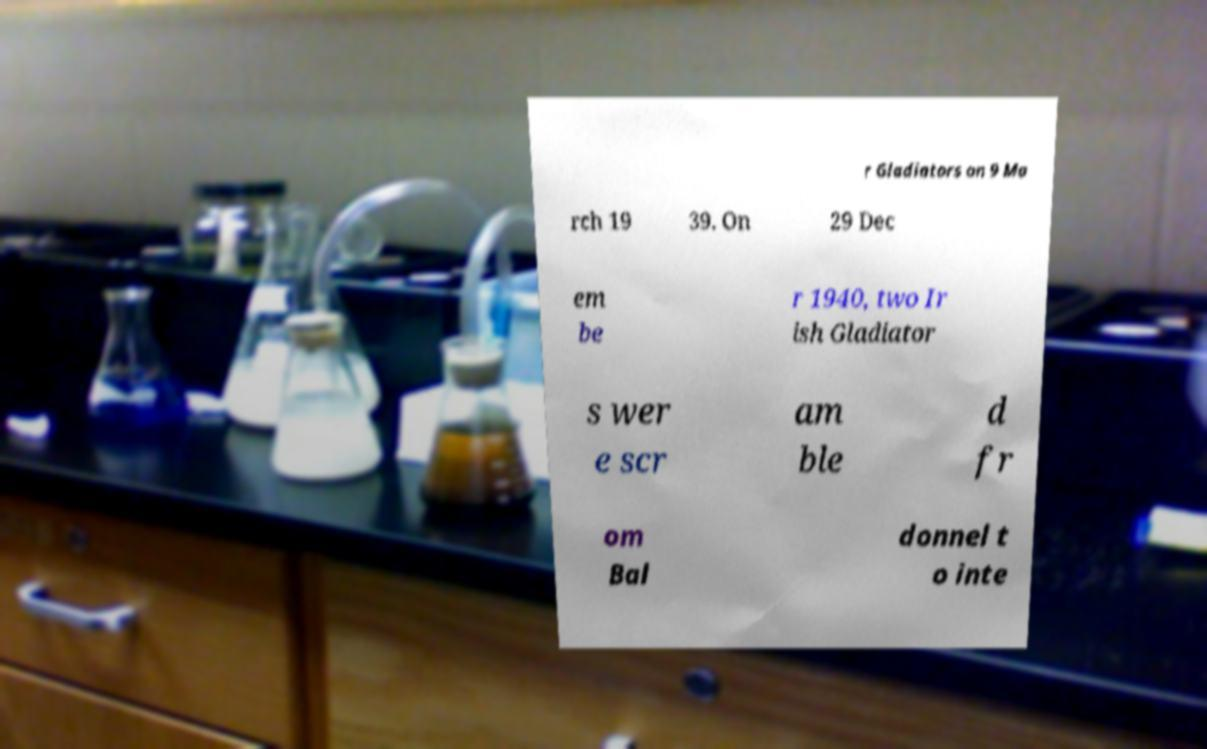Please read and relay the text visible in this image. What does it say? r Gladiators on 9 Ma rch 19 39. On 29 Dec em be r 1940, two Ir ish Gladiator s wer e scr am ble d fr om Bal donnel t o inte 